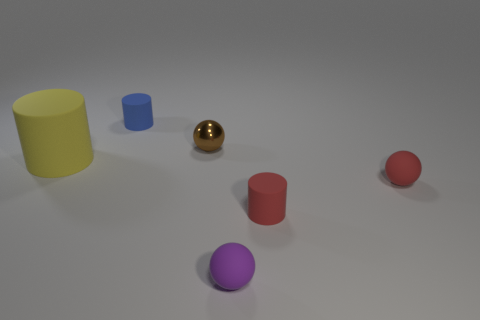Add 3 brown shiny spheres. How many objects exist? 9 Subtract 1 purple spheres. How many objects are left? 5 Subtract all big purple cylinders. Subtract all tiny blue rubber objects. How many objects are left? 5 Add 1 red matte things. How many red matte things are left? 3 Add 1 large purple rubber cylinders. How many large purple rubber cylinders exist? 1 